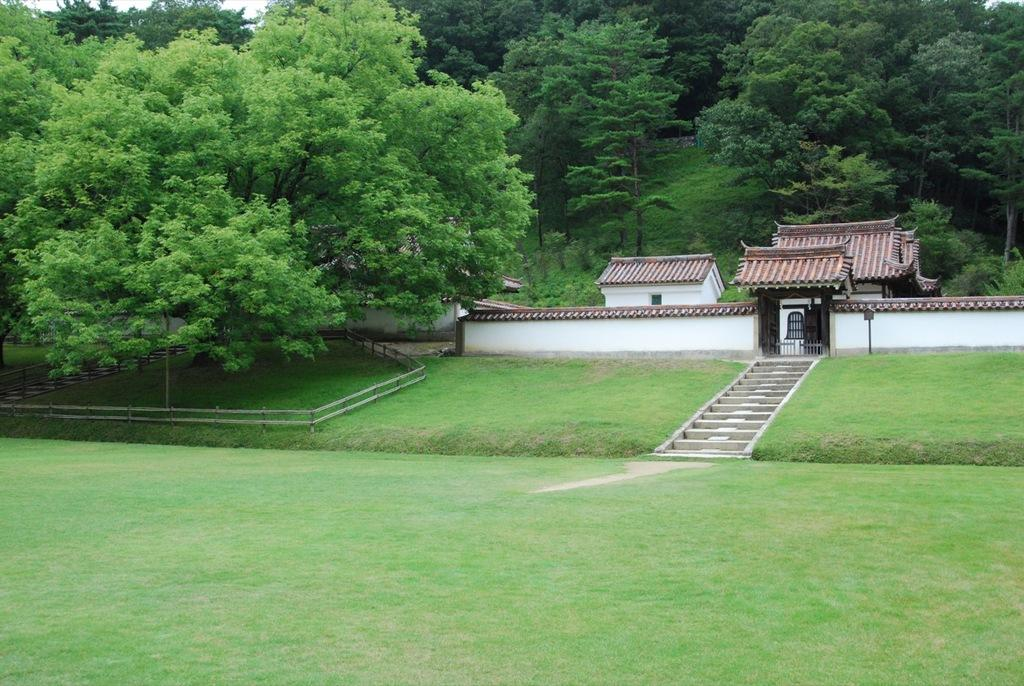What type of structure is visible in the image? There is a house in the image. What architectural feature can be seen near the house? There are stairs in the image. What type of vegetation is present in the image? There is grass and trees in the image. What is the boundary element in the image? There is a fence in the image. What part of the natural environment is visible in the image? The sky is visible in the image. How many kittens are playing on the sidewalk in the image? There are no kittens or sidewalks present in the image. What is the value of the quarter visible in the image? There is no quarter present in the image. 